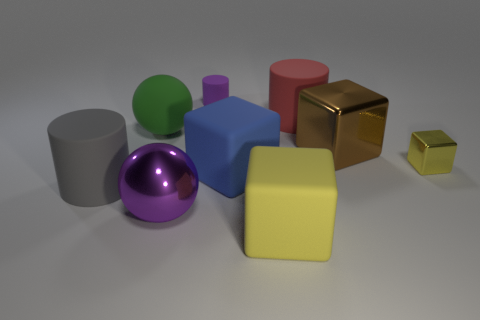What number of large red rubber things have the same shape as the gray object?
Make the answer very short. 1. Are any large green cylinders visible?
Ensure brevity in your answer.  No. Do the tiny purple cylinder and the cylinder in front of the big blue matte cube have the same material?
Give a very brief answer. Yes. What material is the block that is the same size as the purple cylinder?
Provide a short and direct response. Metal. Are there any balls that have the same material as the large gray cylinder?
Provide a succinct answer. Yes. There is a yellow thing on the right side of the rubber object on the right side of the yellow matte object; are there any red things in front of it?
Your response must be concise. No. What is the shape of the purple metal thing that is the same size as the gray matte cylinder?
Make the answer very short. Sphere. There is a cylinder that is in front of the green sphere; does it have the same size as the ball behind the blue cube?
Your answer should be compact. Yes. What number of purple metal cylinders are there?
Provide a succinct answer. 0. How big is the yellow cube that is behind the purple thing that is in front of the large ball behind the tiny yellow shiny block?
Provide a succinct answer. Small. 